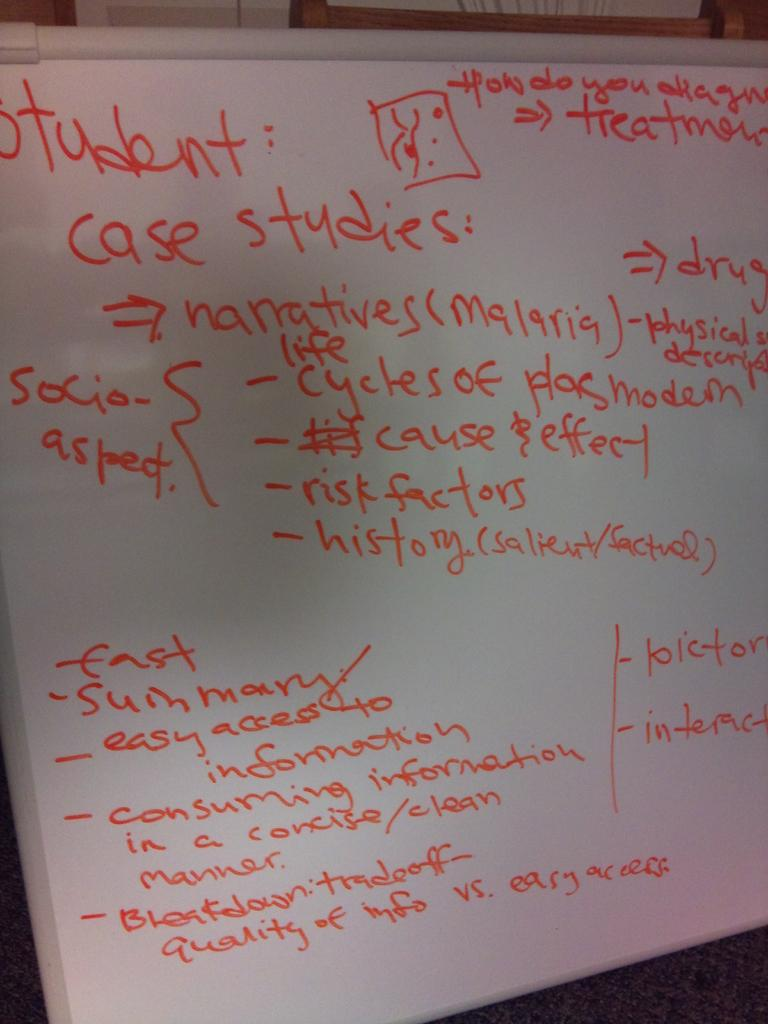<image>
Write a terse but informative summary of the picture. White board which says the word Student on the top. 